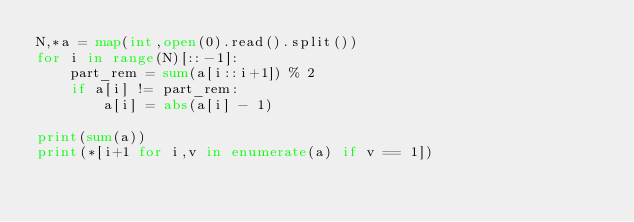Convert code to text. <code><loc_0><loc_0><loc_500><loc_500><_Python_>N,*a = map(int,open(0).read().split())
for i in range(N)[::-1]:
    part_rem = sum(a[i::i+1]) % 2
    if a[i] != part_rem:
        a[i] = abs(a[i] - 1) 

print(sum(a))
print(*[i+1 for i,v in enumerate(a) if v == 1])</code> 